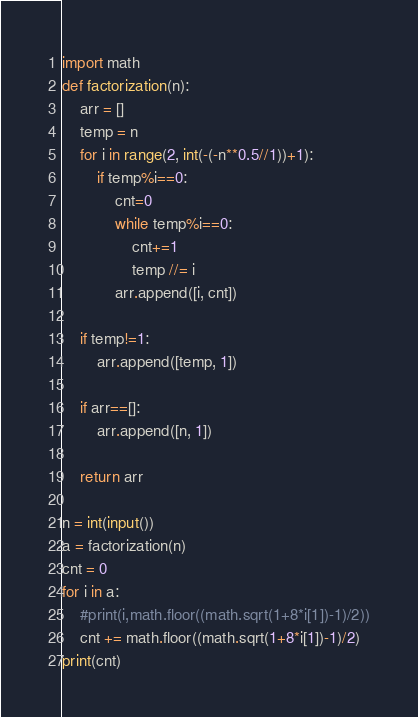<code> <loc_0><loc_0><loc_500><loc_500><_Python_>import math
def factorization(n):
    arr = []
    temp = n
    for i in range(2, int(-(-n**0.5//1))+1):
        if temp%i==0:
            cnt=0
            while temp%i==0:
                cnt+=1
                temp //= i
            arr.append([i, cnt])

    if temp!=1:
        arr.append([temp, 1])

    if arr==[]:
        arr.append([n, 1])

    return arr

n = int(input())
a = factorization(n)
cnt = 0
for i in a:
    #print(i,math.floor((math.sqrt(1+8*i[1])-1)/2))
    cnt += math.floor((math.sqrt(1+8*i[1])-1)/2)
print(cnt)</code> 